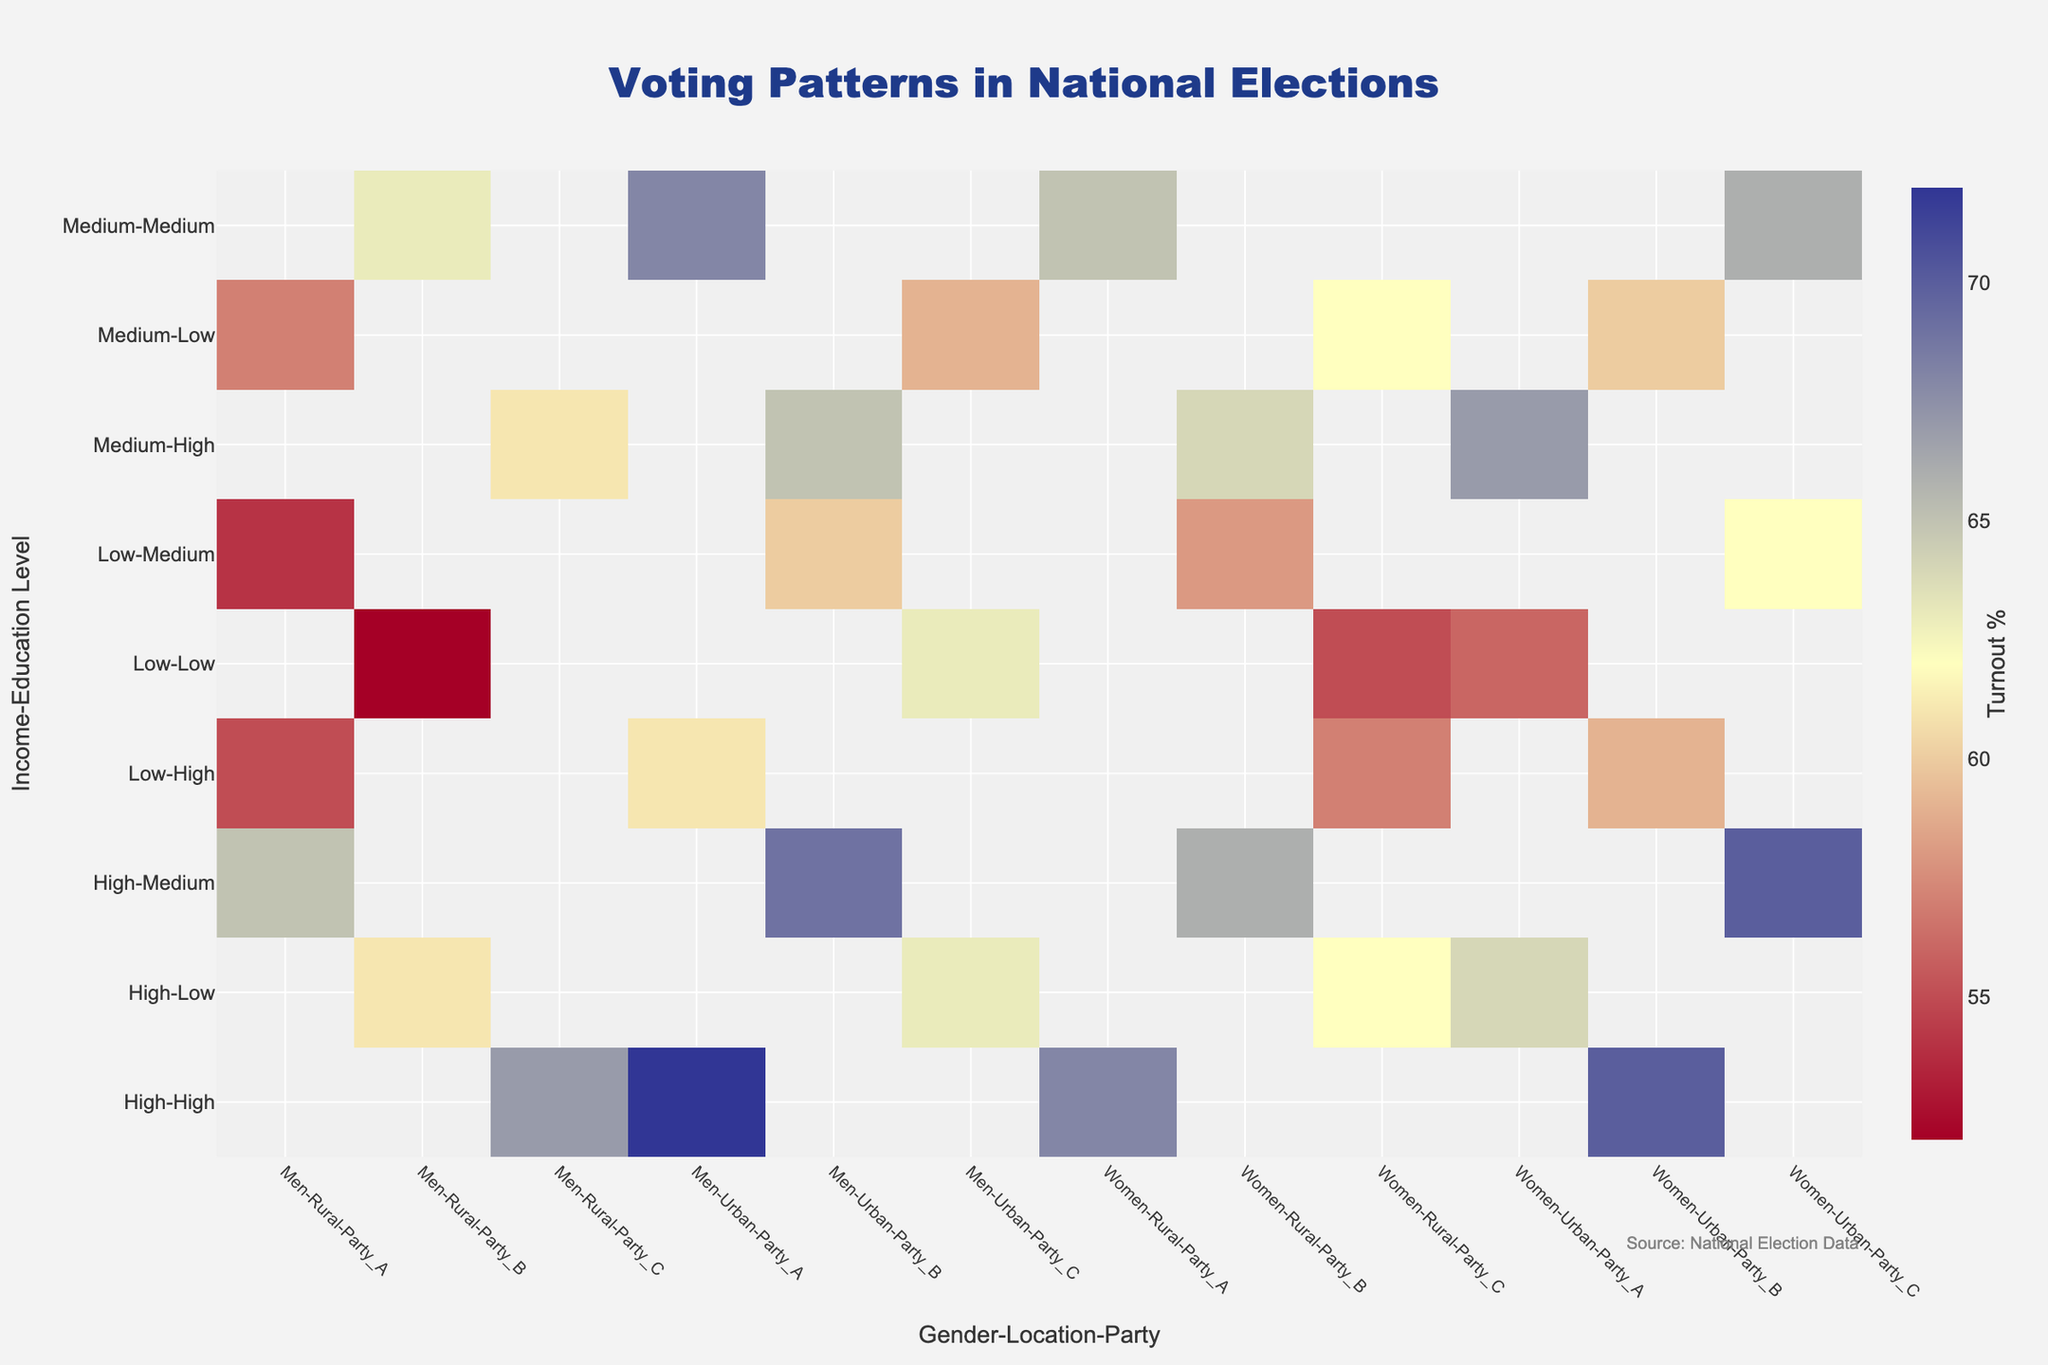What's the highest turnout percentage for high-income high-education women in rural areas? To find this, locate the cell corresponding to "High-High" on the y-axis and "Women-Rural" on the x-axis. The highest turnout percentage is found for "Party A".
Answer: 68 Which party has the highest turnout percentage in urban areas for low-income, medium-education men? Look at the "Low-Medium" row on the y-axis, then find "Men-Urban" on the x-axis. The highest value corresponds to "Party B".
Answer: Party B What is the difference in turnout percentage between medium-income low-education men and women in rural areas? Look at the "Medium-Low" row on the y-axis and compare "Men-Rural" and "Women-Rural" on the x-axis. The turnout percentages for "Men-Rural" and "Women-Rural" are 57% and 62%, respectively. The difference is 62 - 57.
Answer: 5 For which socioeconomic group and gender does Party C have the lowest turnout in rural areas? Scan down the y-axis and look at the "Party C" columns for rural areas in the "Men" and "Women" categories. The lowest turnout for "Party C" is in the "Low-Low" group among "Men".
Answer: Low-Low, Men What is the average turnout percentage for high-income individuals in urban areas? Identify the "High" row on the y-axis and consider both "Men-Urban" and "Women-Urban" from all parties. The turnout percentages are: 72, 70, 69, 70, 63, and 64. Calculate the average: (72 + 70 + 69 + 70 + 63 + 64)/6.
Answer: 68 Which income-education group shows the highest overall turnout percentage regardless of gender or urban-rural status? By examining all y-axis groups, locate the highest single value across all cells. The "Medium-Medium" group has the highest values, with a maximum turnout of 68 for "Party A, Men, Urban".
Answer: Medium-Medium How does the turnout for medium-income, high-education women in urban areas compare between Party A and Party B? Locate the "Medium-High" row on the y-axis and "Women-Urban" on the x-axis. Compare the values for "Party A" and "Party B". "Party A" has 67%, while "Party B" has 65%.
Answer: Party A has a higher turnout What is the overall range of turnout percentages in this heatmap? Identify the minimum and maximum values across the entire heatmap. The smallest value is 52% and the largest is 72%. The range is 72 - 52.
Answer: 20 How does the turnout percentage for low-income, low-education men in rural areas compare to women in urban areas? Locate the "Low-Low" row on the y-axis and compare "Men-Rural" and "Women-Urban". The turnout percentages are 52% and 56%, respectively.
Answer: Women in urban areas have a higher turnout 